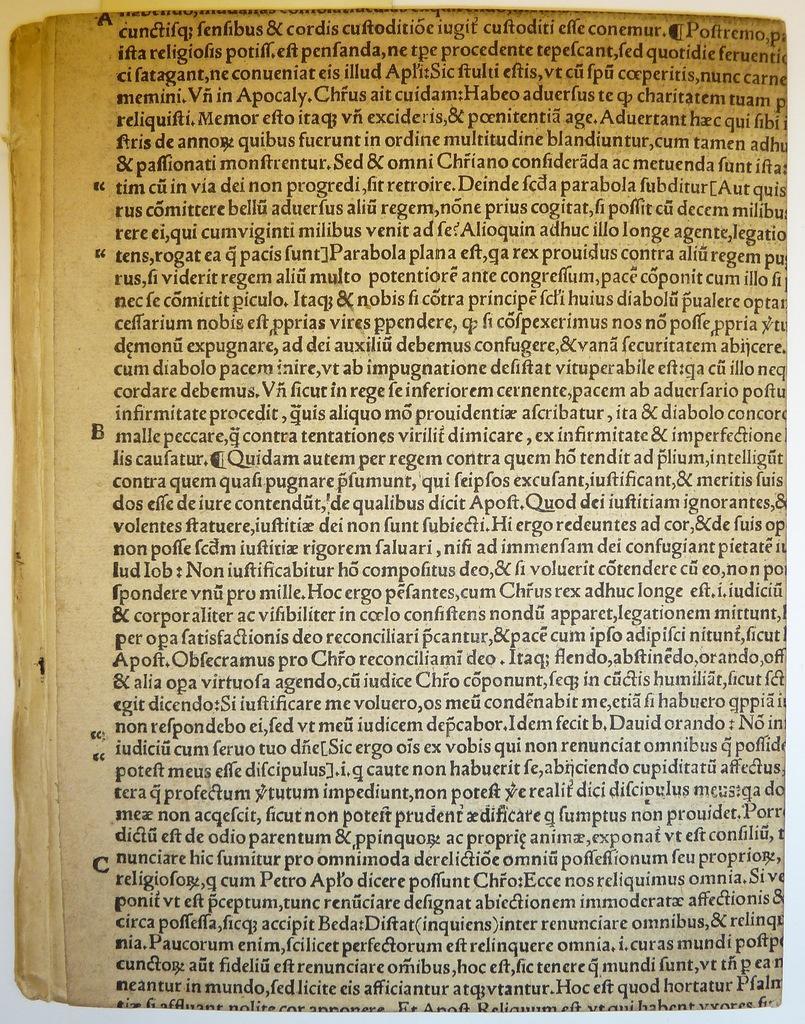Can you describe this image briefly? In this image there is a page of a book, on that there is text. 